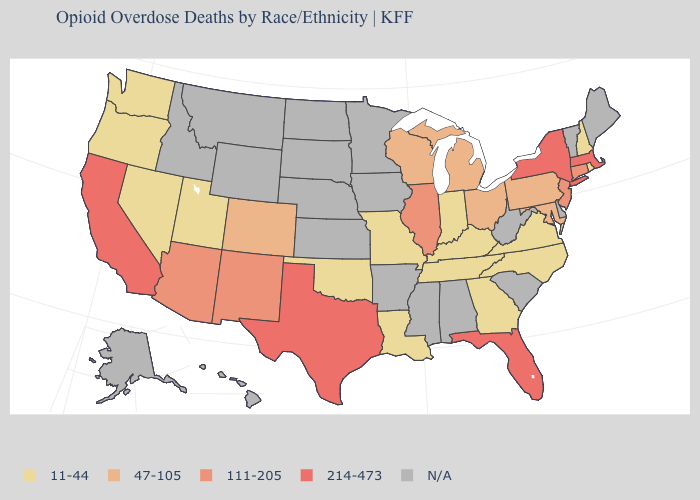What is the highest value in states that border Iowa?
Give a very brief answer. 111-205. Does the first symbol in the legend represent the smallest category?
Answer briefly. Yes. What is the value of Montana?
Answer briefly. N/A. What is the value of Massachusetts?
Write a very short answer. 214-473. What is the value of Arizona?
Quick response, please. 111-205. Which states have the highest value in the USA?
Answer briefly. California, Florida, Massachusetts, New York, Texas. What is the value of Delaware?
Concise answer only. N/A. Name the states that have a value in the range 47-105?
Concise answer only. Colorado, Maryland, Michigan, Ohio, Pennsylvania, Wisconsin. What is the lowest value in states that border Tennessee?
Write a very short answer. 11-44. Among the states that border Missouri , does Illinois have the highest value?
Quick response, please. Yes. Does Washington have the highest value in the USA?
Give a very brief answer. No. Does New York have the highest value in the USA?
Answer briefly. Yes. Does North Carolina have the highest value in the USA?
Quick response, please. No. What is the lowest value in states that border Pennsylvania?
Quick response, please. 47-105. Is the legend a continuous bar?
Answer briefly. No. 